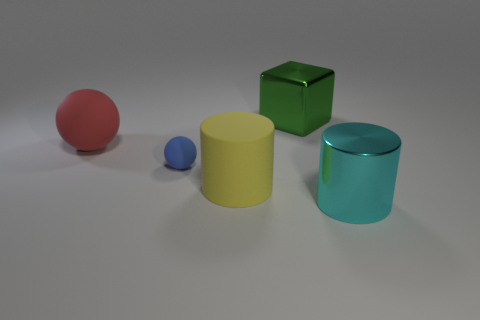Can you suggest a theme that this image could represent? This image, with its neatly arranged geometric objects in various sizes and colors, could represent the theme of simplicity and order. The minimalist composition highlights the beauty of elementary shapes and might evoke a sense of calmness and balance, suitable for educational materials or modern art concepts. 